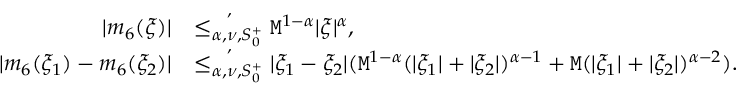<formula> <loc_0><loc_0><loc_500><loc_500>\begin{array} { r l } { | m _ { 6 } ( \xi ) | } & { \overset { , } { \leq _ { \alpha , \nu , S _ { 0 } ^ { + } } } M ^ { 1 - \alpha } | \xi | ^ { \alpha } , } \\ { | m _ { 6 } ( \xi _ { 1 } ) - m _ { 6 } ( \xi _ { 2 } ) | } & { \overset { , } { \leq _ { \alpha , \nu , S _ { 0 } ^ { + } } } | \xi _ { 1 } - \xi _ { 2 } | ( M ^ { 1 - \alpha } ( | \xi _ { 1 } | + | \xi _ { 2 } | ) ^ { \alpha - 1 } + M ( | \xi _ { 1 } | + | \xi _ { 2 } | ) ^ { \alpha - 2 } ) . } \end{array}</formula> 